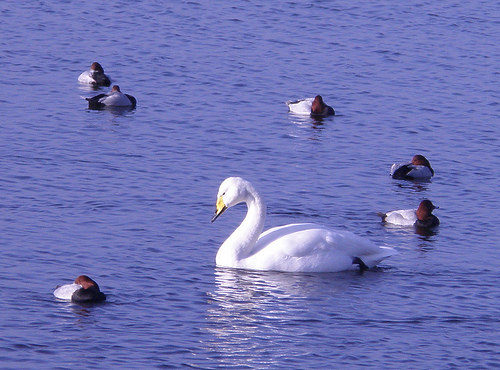<image>
Is there a duck to the left of the goose? Yes. From this viewpoint, the duck is positioned to the left side relative to the goose. 